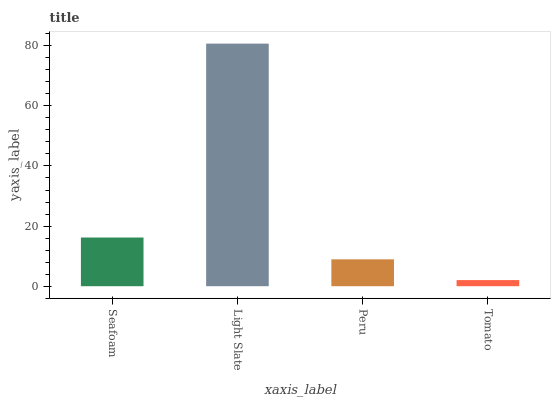Is Peru the minimum?
Answer yes or no. No. Is Peru the maximum?
Answer yes or no. No. Is Light Slate greater than Peru?
Answer yes or no. Yes. Is Peru less than Light Slate?
Answer yes or no. Yes. Is Peru greater than Light Slate?
Answer yes or no. No. Is Light Slate less than Peru?
Answer yes or no. No. Is Seafoam the high median?
Answer yes or no. Yes. Is Peru the low median?
Answer yes or no. Yes. Is Tomato the high median?
Answer yes or no. No. Is Tomato the low median?
Answer yes or no. No. 